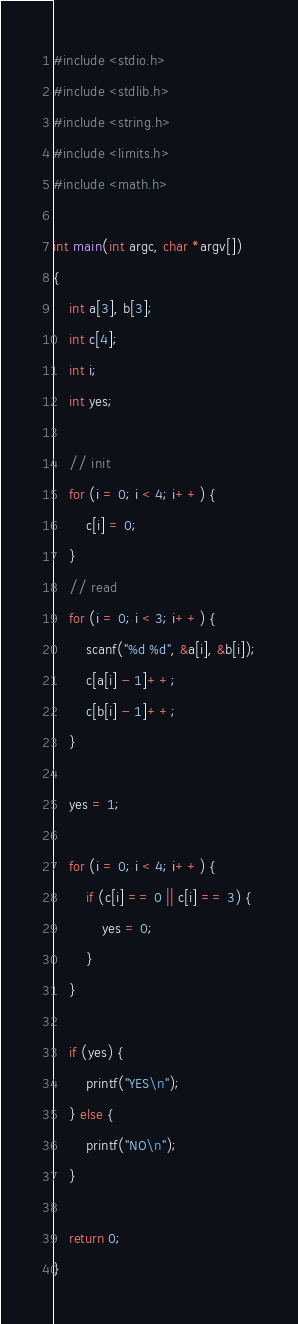Convert code to text. <code><loc_0><loc_0><loc_500><loc_500><_C_>#include <stdio.h>
#include <stdlib.h>
#include <string.h>
#include <limits.h>
#include <math.h>

int main(int argc, char *argv[])
{
    int a[3], b[3];
    int c[4];
    int i;
    int yes;

    // init
    for (i = 0; i < 4; i++) {
        c[i] = 0;
    }
    // read
    for (i = 0; i < 3; i++) {
        scanf("%d %d", &a[i], &b[i]);
        c[a[i] - 1]++;
        c[b[i] - 1]++;
    }

    yes = 1;

    for (i = 0; i < 4; i++) {
        if (c[i] == 0 || c[i] == 3) {
            yes = 0;
        }
    }

    if (yes) {
        printf("YES\n");
    } else {
        printf("NO\n");
    }

    return 0;
}
</code> 